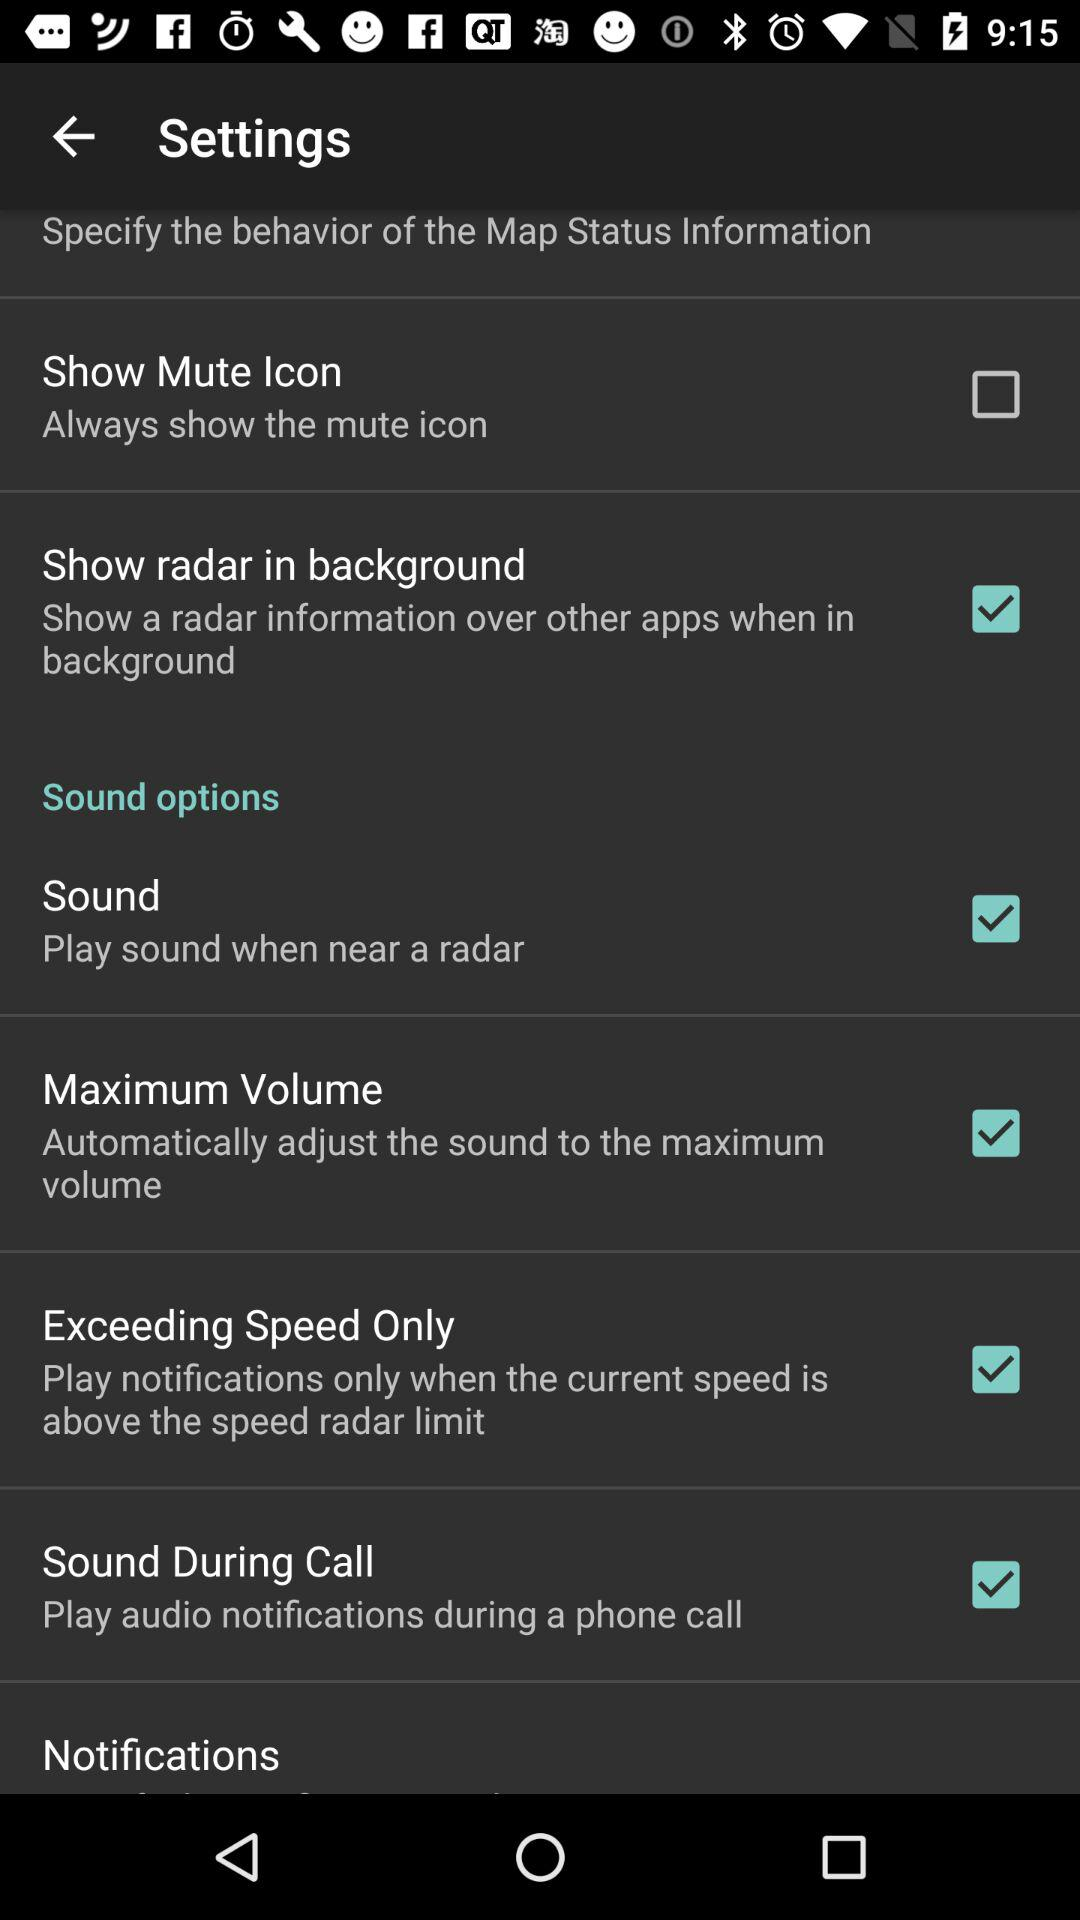What are the selected settings? The selected settings are: "Show radar in background", "Sound", "Maximum Volume", "Exceeding Speed Only", and "Sound During Call". 